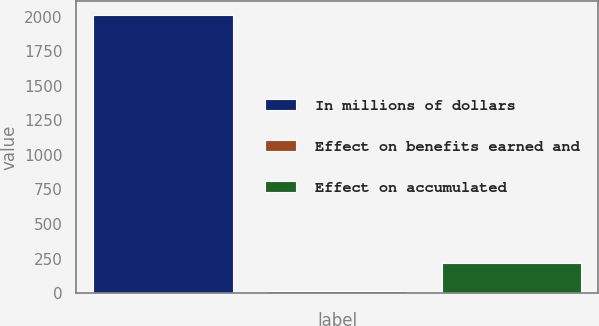Convert chart to OTSL. <chart><loc_0><loc_0><loc_500><loc_500><bar_chart><fcel>In millions of dollars<fcel>Effect on benefits earned and<fcel>Effect on accumulated<nl><fcel>2014<fcel>14<fcel>214<nl></chart> 